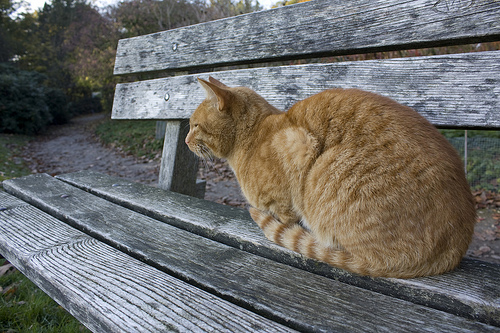Is the grass below an airplane? No, the grass is not below an airplane. 